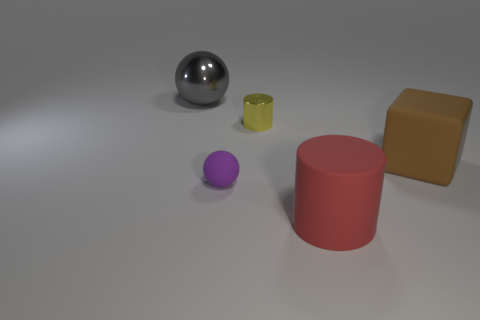Is the red rubber cylinder the same size as the shiny cylinder?
Give a very brief answer. No. There is a big object that is in front of the large ball and behind the purple sphere; what material is it made of?
Ensure brevity in your answer.  Rubber. How many other objects are there of the same material as the small yellow thing?
Offer a terse response. 1. How many large matte cylinders have the same color as the large cube?
Make the answer very short. 0. How big is the object left of the sphere that is in front of the small thing behind the large brown matte cube?
Your response must be concise. Large. What number of matte things are either large green cylinders or cylinders?
Your answer should be very brief. 1. There is a tiny yellow metal object; does it have the same shape as the matte object in front of the small purple matte ball?
Offer a very short reply. Yes. Are there more shiny spheres that are behind the tiny purple thing than big brown rubber blocks that are on the left side of the red matte cylinder?
Keep it short and to the point. Yes. Is there any other thing of the same color as the large shiny sphere?
Your answer should be very brief. No. Is there a purple object behind the matte thing that is behind the matte thing that is left of the small yellow cylinder?
Make the answer very short. No. 